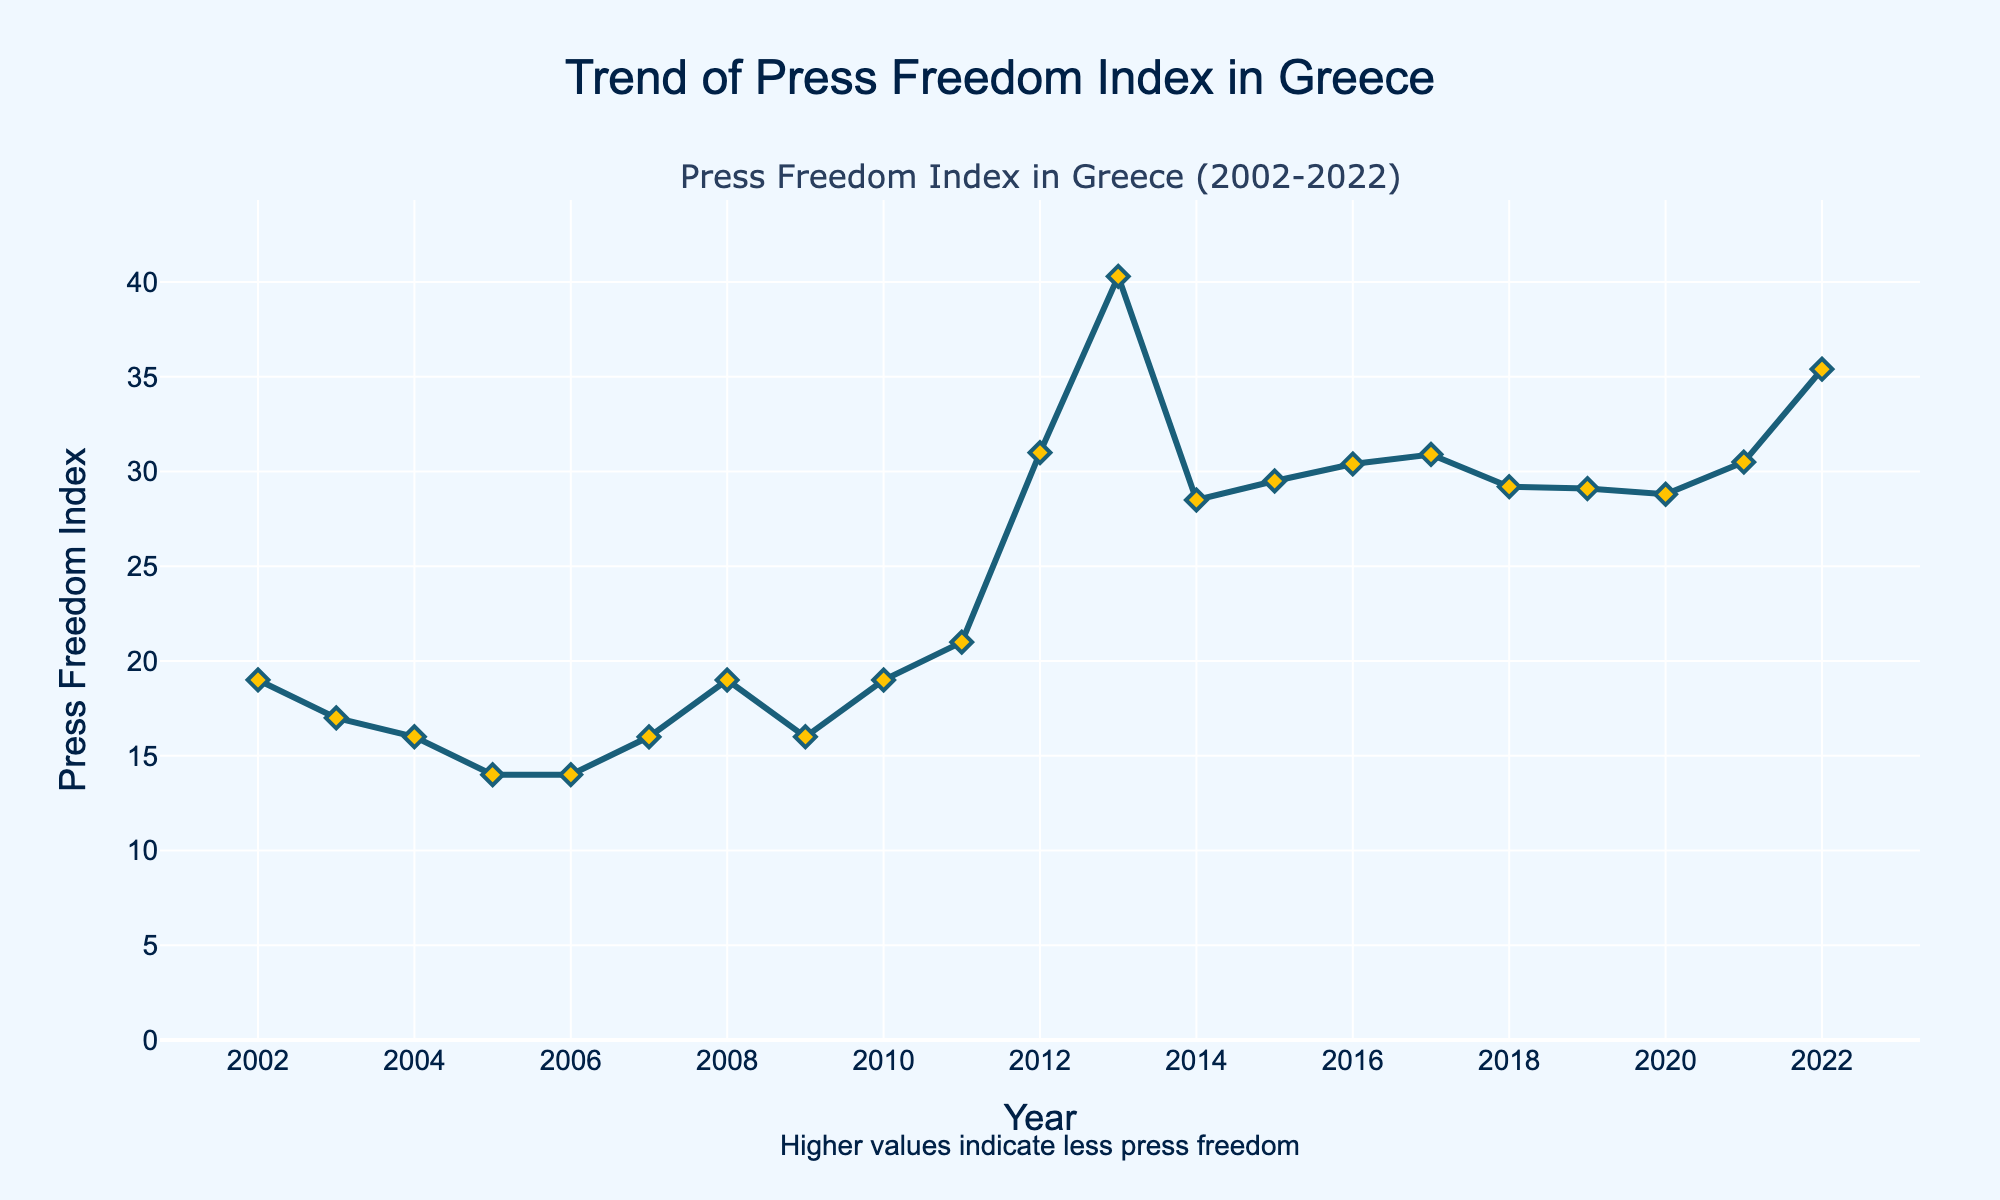What is the trend of the Press Freedom Index in Greece from 2002 to 2022? The Press Freedom Index shows significant fluctuation over the years, with values initially around 16-19, a sharp increase starting in 2011 and peaking in 2013 at 40.3, followed by a decrease, then another increasing trend reaching 35.4 in 2022. The general trend suggests declining press freedom over the years.
Answer: It declines, with fluctuations In which year did Greece experience the highest Press Freedom Index? By examining the peaks in the line chart, the highest Press Freedom Index is in the year 2013, represented by the highest point on the plot.
Answer: 2013 How many times did the Press Freedom Index increase consecutively? By looking at the trend of the line, the indices increase consecutively from 2002 to 2005, from 2011 to 2013, and from 2021 to 2022.
Answer: 3 times What is the overall difference in the Press Freedom Index from 2002 to 2022? The difference can be calculated by subtracting the Press Freedom Index in 2002 (19.0) from the index in 2022 (35.4). This yields 35.4 - 19.0 = 16.4.
Answer: 16.4 During which period did Greece see the most significant increase in the Press Freedom Index? Comparing the slopes between different years, the steepest rise is observed between 2011 and 2013, where the index increases from 21.0 to 40.3.
Answer: 2011-2013 From which year to which year did the Press Freedom Index decrease consecutively? By observing the plot, the Press Freedom Index decreases consecutively in the period from 2013 to 2018.
Answer: 2013-2018 What was the average Press Freedom Index from 2002 to 2010? Calculate the mean of the Press Freedom Index values from 2002 to 2010. First sum up these values (19.0 + 17.0 + 16.0 + 14.0 + 14.0 + 16.0 + 19.0 + 16.0 + 19.0), which equals 150. Divide by the number of years (9), resulting in 150 / 9 ≈ 16.67.
Answer: 16.67 Which year had a higher Press Freedom Index, 2007 or 2019, and by how much? In 2007, the index was 16.0, and in 2019, it was 29.1. Subtracting the two values gives 29.1 - 16.0 = 13.1.
Answer: 2019 by 13.1 What is the median Press Freedom Index value from 2002 to 2022? To find the median, list the values in ascending order and find the middle value. With 21 years of data, the median is the 11th value. The sorted list is [14.0, 14.0, 16.0, 16.0, 16.0, 16.0, 17.0, 19.0, 19.0, 19.0, 21.0, 28.5, 28.8, 29.1, 29.2, 29.5, 30.4, 30.5, 30.9, 31.0, 35.4], so the median value is 21.0.
Answer: 21.0 